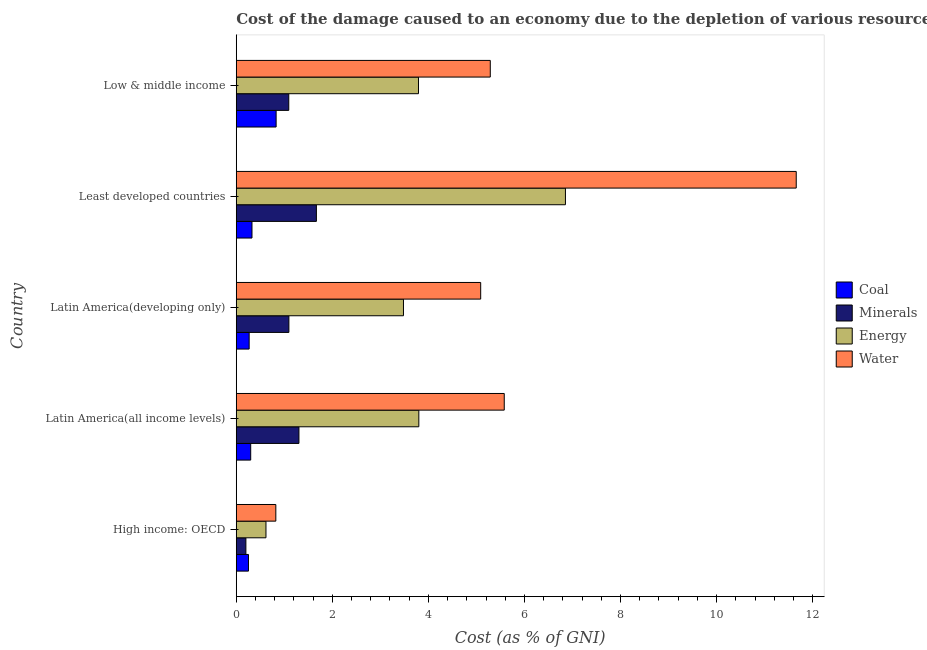How many groups of bars are there?
Keep it short and to the point. 5. Are the number of bars per tick equal to the number of legend labels?
Provide a succinct answer. Yes. How many bars are there on the 4th tick from the top?
Your answer should be compact. 4. What is the label of the 3rd group of bars from the top?
Provide a short and direct response. Latin America(developing only). In how many cases, is the number of bars for a given country not equal to the number of legend labels?
Offer a very short reply. 0. What is the cost of damage due to depletion of water in Latin America(all income levels)?
Give a very brief answer. 5.58. Across all countries, what is the maximum cost of damage due to depletion of coal?
Offer a very short reply. 0.83. Across all countries, what is the minimum cost of damage due to depletion of minerals?
Your answer should be compact. 0.2. In which country was the cost of damage due to depletion of energy maximum?
Keep it short and to the point. Least developed countries. In which country was the cost of damage due to depletion of coal minimum?
Your answer should be very brief. High income: OECD. What is the total cost of damage due to depletion of water in the graph?
Give a very brief answer. 28.44. What is the difference between the cost of damage due to depletion of coal in Latin America(developing only) and that in Low & middle income?
Your answer should be compact. -0.56. What is the difference between the cost of damage due to depletion of minerals in Low & middle income and the cost of damage due to depletion of energy in Latin America(developing only)?
Make the answer very short. -2.39. What is the average cost of damage due to depletion of energy per country?
Give a very brief answer. 3.71. What is the ratio of the cost of damage due to depletion of minerals in High income: OECD to that in Least developed countries?
Offer a terse response. 0.12. What is the difference between the highest and the second highest cost of damage due to depletion of water?
Make the answer very short. 6.08. What is the difference between the highest and the lowest cost of damage due to depletion of water?
Ensure brevity in your answer.  10.83. In how many countries, is the cost of damage due to depletion of minerals greater than the average cost of damage due to depletion of minerals taken over all countries?
Your answer should be compact. 4. Is the sum of the cost of damage due to depletion of minerals in High income: OECD and Latin America(all income levels) greater than the maximum cost of damage due to depletion of energy across all countries?
Offer a very short reply. No. Is it the case that in every country, the sum of the cost of damage due to depletion of water and cost of damage due to depletion of minerals is greater than the sum of cost of damage due to depletion of coal and cost of damage due to depletion of energy?
Offer a very short reply. No. What does the 2nd bar from the top in Least developed countries represents?
Provide a succinct answer. Energy. What does the 4th bar from the bottom in Least developed countries represents?
Make the answer very short. Water. Is it the case that in every country, the sum of the cost of damage due to depletion of coal and cost of damage due to depletion of minerals is greater than the cost of damage due to depletion of energy?
Ensure brevity in your answer.  No. How many bars are there?
Offer a very short reply. 20. What is the difference between two consecutive major ticks on the X-axis?
Make the answer very short. 2. Does the graph contain any zero values?
Keep it short and to the point. No. Where does the legend appear in the graph?
Make the answer very short. Center right. How many legend labels are there?
Keep it short and to the point. 4. How are the legend labels stacked?
Offer a very short reply. Vertical. What is the title of the graph?
Give a very brief answer. Cost of the damage caused to an economy due to the depletion of various resources in 2012 . What is the label or title of the X-axis?
Ensure brevity in your answer.  Cost (as % of GNI). What is the Cost (as % of GNI) in Coal in High income: OECD?
Give a very brief answer. 0.25. What is the Cost (as % of GNI) in Minerals in High income: OECD?
Make the answer very short. 0.2. What is the Cost (as % of GNI) of Energy in High income: OECD?
Your answer should be very brief. 0.62. What is the Cost (as % of GNI) in Water in High income: OECD?
Give a very brief answer. 0.82. What is the Cost (as % of GNI) in Coal in Latin America(all income levels)?
Ensure brevity in your answer.  0.3. What is the Cost (as % of GNI) in Minerals in Latin America(all income levels)?
Offer a terse response. 1.3. What is the Cost (as % of GNI) of Energy in Latin America(all income levels)?
Your answer should be very brief. 3.8. What is the Cost (as % of GNI) in Water in Latin America(all income levels)?
Offer a terse response. 5.58. What is the Cost (as % of GNI) in Coal in Latin America(developing only)?
Your answer should be compact. 0.27. What is the Cost (as % of GNI) in Minerals in Latin America(developing only)?
Make the answer very short. 1.1. What is the Cost (as % of GNI) in Energy in Latin America(developing only)?
Your response must be concise. 3.48. What is the Cost (as % of GNI) of Water in Latin America(developing only)?
Make the answer very short. 5.09. What is the Cost (as % of GNI) of Coal in Least developed countries?
Provide a short and direct response. 0.33. What is the Cost (as % of GNI) of Minerals in Least developed countries?
Your answer should be very brief. 1.67. What is the Cost (as % of GNI) in Energy in Least developed countries?
Your answer should be compact. 6.85. What is the Cost (as % of GNI) of Water in Least developed countries?
Make the answer very short. 11.66. What is the Cost (as % of GNI) of Coal in Low & middle income?
Make the answer very short. 0.83. What is the Cost (as % of GNI) of Minerals in Low & middle income?
Offer a very short reply. 1.09. What is the Cost (as % of GNI) in Energy in Low & middle income?
Your answer should be compact. 3.79. What is the Cost (as % of GNI) in Water in Low & middle income?
Provide a short and direct response. 5.29. Across all countries, what is the maximum Cost (as % of GNI) in Coal?
Give a very brief answer. 0.83. Across all countries, what is the maximum Cost (as % of GNI) in Minerals?
Give a very brief answer. 1.67. Across all countries, what is the maximum Cost (as % of GNI) of Energy?
Provide a succinct answer. 6.85. Across all countries, what is the maximum Cost (as % of GNI) of Water?
Keep it short and to the point. 11.66. Across all countries, what is the minimum Cost (as % of GNI) in Coal?
Provide a short and direct response. 0.25. Across all countries, what is the minimum Cost (as % of GNI) of Minerals?
Your answer should be very brief. 0.2. Across all countries, what is the minimum Cost (as % of GNI) of Energy?
Offer a terse response. 0.62. Across all countries, what is the minimum Cost (as % of GNI) of Water?
Your response must be concise. 0.82. What is the total Cost (as % of GNI) of Coal in the graph?
Offer a terse response. 1.98. What is the total Cost (as % of GNI) of Minerals in the graph?
Your answer should be very brief. 5.36. What is the total Cost (as % of GNI) in Energy in the graph?
Provide a short and direct response. 18.55. What is the total Cost (as % of GNI) in Water in the graph?
Your answer should be compact. 28.44. What is the difference between the Cost (as % of GNI) in Coal in High income: OECD and that in Latin America(all income levels)?
Offer a terse response. -0.05. What is the difference between the Cost (as % of GNI) of Minerals in High income: OECD and that in Latin America(all income levels)?
Keep it short and to the point. -1.1. What is the difference between the Cost (as % of GNI) in Energy in High income: OECD and that in Latin America(all income levels)?
Your response must be concise. -3.18. What is the difference between the Cost (as % of GNI) in Water in High income: OECD and that in Latin America(all income levels)?
Your answer should be compact. -4.76. What is the difference between the Cost (as % of GNI) of Coal in High income: OECD and that in Latin America(developing only)?
Offer a very short reply. -0.01. What is the difference between the Cost (as % of GNI) of Minerals in High income: OECD and that in Latin America(developing only)?
Offer a very short reply. -0.9. What is the difference between the Cost (as % of GNI) in Energy in High income: OECD and that in Latin America(developing only)?
Offer a very short reply. -2.86. What is the difference between the Cost (as % of GNI) in Water in High income: OECD and that in Latin America(developing only)?
Your answer should be very brief. -4.26. What is the difference between the Cost (as % of GNI) of Coal in High income: OECD and that in Least developed countries?
Your answer should be very brief. -0.07. What is the difference between the Cost (as % of GNI) of Minerals in High income: OECD and that in Least developed countries?
Make the answer very short. -1.47. What is the difference between the Cost (as % of GNI) of Energy in High income: OECD and that in Least developed countries?
Make the answer very short. -6.23. What is the difference between the Cost (as % of GNI) in Water in High income: OECD and that in Least developed countries?
Provide a short and direct response. -10.83. What is the difference between the Cost (as % of GNI) in Coal in High income: OECD and that in Low & middle income?
Keep it short and to the point. -0.58. What is the difference between the Cost (as % of GNI) of Minerals in High income: OECD and that in Low & middle income?
Provide a succinct answer. -0.89. What is the difference between the Cost (as % of GNI) of Energy in High income: OECD and that in Low & middle income?
Offer a terse response. -3.17. What is the difference between the Cost (as % of GNI) of Water in High income: OECD and that in Low & middle income?
Ensure brevity in your answer.  -4.46. What is the difference between the Cost (as % of GNI) of Coal in Latin America(all income levels) and that in Latin America(developing only)?
Provide a short and direct response. 0.03. What is the difference between the Cost (as % of GNI) of Minerals in Latin America(all income levels) and that in Latin America(developing only)?
Offer a very short reply. 0.21. What is the difference between the Cost (as % of GNI) in Energy in Latin America(all income levels) and that in Latin America(developing only)?
Offer a terse response. 0.32. What is the difference between the Cost (as % of GNI) in Water in Latin America(all income levels) and that in Latin America(developing only)?
Offer a terse response. 0.49. What is the difference between the Cost (as % of GNI) in Coal in Latin America(all income levels) and that in Least developed countries?
Your answer should be very brief. -0.03. What is the difference between the Cost (as % of GNI) of Minerals in Latin America(all income levels) and that in Least developed countries?
Offer a very short reply. -0.36. What is the difference between the Cost (as % of GNI) in Energy in Latin America(all income levels) and that in Least developed countries?
Make the answer very short. -3.05. What is the difference between the Cost (as % of GNI) in Water in Latin America(all income levels) and that in Least developed countries?
Ensure brevity in your answer.  -6.08. What is the difference between the Cost (as % of GNI) of Coal in Latin America(all income levels) and that in Low & middle income?
Provide a short and direct response. -0.53. What is the difference between the Cost (as % of GNI) of Minerals in Latin America(all income levels) and that in Low & middle income?
Give a very brief answer. 0.21. What is the difference between the Cost (as % of GNI) in Energy in Latin America(all income levels) and that in Low & middle income?
Your answer should be compact. 0.01. What is the difference between the Cost (as % of GNI) in Water in Latin America(all income levels) and that in Low & middle income?
Make the answer very short. 0.29. What is the difference between the Cost (as % of GNI) of Coal in Latin America(developing only) and that in Least developed countries?
Provide a short and direct response. -0.06. What is the difference between the Cost (as % of GNI) of Minerals in Latin America(developing only) and that in Least developed countries?
Your answer should be very brief. -0.57. What is the difference between the Cost (as % of GNI) of Energy in Latin America(developing only) and that in Least developed countries?
Provide a succinct answer. -3.37. What is the difference between the Cost (as % of GNI) in Water in Latin America(developing only) and that in Least developed countries?
Offer a terse response. -6.57. What is the difference between the Cost (as % of GNI) in Coal in Latin America(developing only) and that in Low & middle income?
Make the answer very short. -0.56. What is the difference between the Cost (as % of GNI) in Minerals in Latin America(developing only) and that in Low & middle income?
Your answer should be compact. 0. What is the difference between the Cost (as % of GNI) in Energy in Latin America(developing only) and that in Low & middle income?
Ensure brevity in your answer.  -0.31. What is the difference between the Cost (as % of GNI) of Water in Latin America(developing only) and that in Low & middle income?
Provide a succinct answer. -0.2. What is the difference between the Cost (as % of GNI) in Coal in Least developed countries and that in Low & middle income?
Provide a succinct answer. -0.5. What is the difference between the Cost (as % of GNI) of Minerals in Least developed countries and that in Low & middle income?
Offer a very short reply. 0.58. What is the difference between the Cost (as % of GNI) in Energy in Least developed countries and that in Low & middle income?
Offer a very short reply. 3.06. What is the difference between the Cost (as % of GNI) in Water in Least developed countries and that in Low & middle income?
Give a very brief answer. 6.37. What is the difference between the Cost (as % of GNI) of Coal in High income: OECD and the Cost (as % of GNI) of Minerals in Latin America(all income levels)?
Make the answer very short. -1.05. What is the difference between the Cost (as % of GNI) of Coal in High income: OECD and the Cost (as % of GNI) of Energy in Latin America(all income levels)?
Your answer should be compact. -3.55. What is the difference between the Cost (as % of GNI) in Coal in High income: OECD and the Cost (as % of GNI) in Water in Latin America(all income levels)?
Give a very brief answer. -5.32. What is the difference between the Cost (as % of GNI) of Minerals in High income: OECD and the Cost (as % of GNI) of Energy in Latin America(all income levels)?
Provide a succinct answer. -3.6. What is the difference between the Cost (as % of GNI) of Minerals in High income: OECD and the Cost (as % of GNI) of Water in Latin America(all income levels)?
Ensure brevity in your answer.  -5.38. What is the difference between the Cost (as % of GNI) of Energy in High income: OECD and the Cost (as % of GNI) of Water in Latin America(all income levels)?
Provide a short and direct response. -4.96. What is the difference between the Cost (as % of GNI) in Coal in High income: OECD and the Cost (as % of GNI) in Minerals in Latin America(developing only)?
Keep it short and to the point. -0.84. What is the difference between the Cost (as % of GNI) of Coal in High income: OECD and the Cost (as % of GNI) of Energy in Latin America(developing only)?
Your answer should be compact. -3.23. What is the difference between the Cost (as % of GNI) in Coal in High income: OECD and the Cost (as % of GNI) in Water in Latin America(developing only)?
Offer a very short reply. -4.83. What is the difference between the Cost (as % of GNI) of Minerals in High income: OECD and the Cost (as % of GNI) of Energy in Latin America(developing only)?
Your response must be concise. -3.28. What is the difference between the Cost (as % of GNI) of Minerals in High income: OECD and the Cost (as % of GNI) of Water in Latin America(developing only)?
Ensure brevity in your answer.  -4.89. What is the difference between the Cost (as % of GNI) of Energy in High income: OECD and the Cost (as % of GNI) of Water in Latin America(developing only)?
Keep it short and to the point. -4.47. What is the difference between the Cost (as % of GNI) of Coal in High income: OECD and the Cost (as % of GNI) of Minerals in Least developed countries?
Offer a very short reply. -1.41. What is the difference between the Cost (as % of GNI) of Coal in High income: OECD and the Cost (as % of GNI) of Energy in Least developed countries?
Provide a short and direct response. -6.6. What is the difference between the Cost (as % of GNI) in Coal in High income: OECD and the Cost (as % of GNI) in Water in Least developed countries?
Your response must be concise. -11.4. What is the difference between the Cost (as % of GNI) in Minerals in High income: OECD and the Cost (as % of GNI) in Energy in Least developed countries?
Provide a succinct answer. -6.65. What is the difference between the Cost (as % of GNI) in Minerals in High income: OECD and the Cost (as % of GNI) in Water in Least developed countries?
Provide a succinct answer. -11.46. What is the difference between the Cost (as % of GNI) of Energy in High income: OECD and the Cost (as % of GNI) of Water in Least developed countries?
Provide a short and direct response. -11.04. What is the difference between the Cost (as % of GNI) of Coal in High income: OECD and the Cost (as % of GNI) of Minerals in Low & middle income?
Your answer should be very brief. -0.84. What is the difference between the Cost (as % of GNI) of Coal in High income: OECD and the Cost (as % of GNI) of Energy in Low & middle income?
Your answer should be very brief. -3.54. What is the difference between the Cost (as % of GNI) in Coal in High income: OECD and the Cost (as % of GNI) in Water in Low & middle income?
Offer a very short reply. -5.03. What is the difference between the Cost (as % of GNI) of Minerals in High income: OECD and the Cost (as % of GNI) of Energy in Low & middle income?
Provide a short and direct response. -3.59. What is the difference between the Cost (as % of GNI) in Minerals in High income: OECD and the Cost (as % of GNI) in Water in Low & middle income?
Provide a succinct answer. -5.09. What is the difference between the Cost (as % of GNI) in Energy in High income: OECD and the Cost (as % of GNI) in Water in Low & middle income?
Ensure brevity in your answer.  -4.67. What is the difference between the Cost (as % of GNI) in Coal in Latin America(all income levels) and the Cost (as % of GNI) in Minerals in Latin America(developing only)?
Ensure brevity in your answer.  -0.8. What is the difference between the Cost (as % of GNI) in Coal in Latin America(all income levels) and the Cost (as % of GNI) in Energy in Latin America(developing only)?
Your answer should be very brief. -3.18. What is the difference between the Cost (as % of GNI) of Coal in Latin America(all income levels) and the Cost (as % of GNI) of Water in Latin America(developing only)?
Keep it short and to the point. -4.79. What is the difference between the Cost (as % of GNI) in Minerals in Latin America(all income levels) and the Cost (as % of GNI) in Energy in Latin America(developing only)?
Make the answer very short. -2.18. What is the difference between the Cost (as % of GNI) in Minerals in Latin America(all income levels) and the Cost (as % of GNI) in Water in Latin America(developing only)?
Ensure brevity in your answer.  -3.78. What is the difference between the Cost (as % of GNI) in Energy in Latin America(all income levels) and the Cost (as % of GNI) in Water in Latin America(developing only)?
Provide a succinct answer. -1.29. What is the difference between the Cost (as % of GNI) in Coal in Latin America(all income levels) and the Cost (as % of GNI) in Minerals in Least developed countries?
Provide a short and direct response. -1.37. What is the difference between the Cost (as % of GNI) in Coal in Latin America(all income levels) and the Cost (as % of GNI) in Energy in Least developed countries?
Offer a terse response. -6.55. What is the difference between the Cost (as % of GNI) of Coal in Latin America(all income levels) and the Cost (as % of GNI) of Water in Least developed countries?
Keep it short and to the point. -11.36. What is the difference between the Cost (as % of GNI) in Minerals in Latin America(all income levels) and the Cost (as % of GNI) in Energy in Least developed countries?
Provide a succinct answer. -5.55. What is the difference between the Cost (as % of GNI) of Minerals in Latin America(all income levels) and the Cost (as % of GNI) of Water in Least developed countries?
Offer a terse response. -10.35. What is the difference between the Cost (as % of GNI) in Energy in Latin America(all income levels) and the Cost (as % of GNI) in Water in Least developed countries?
Provide a succinct answer. -7.86. What is the difference between the Cost (as % of GNI) of Coal in Latin America(all income levels) and the Cost (as % of GNI) of Minerals in Low & middle income?
Offer a terse response. -0.79. What is the difference between the Cost (as % of GNI) of Coal in Latin America(all income levels) and the Cost (as % of GNI) of Energy in Low & middle income?
Provide a short and direct response. -3.49. What is the difference between the Cost (as % of GNI) in Coal in Latin America(all income levels) and the Cost (as % of GNI) in Water in Low & middle income?
Ensure brevity in your answer.  -4.99. What is the difference between the Cost (as % of GNI) in Minerals in Latin America(all income levels) and the Cost (as % of GNI) in Energy in Low & middle income?
Your answer should be compact. -2.49. What is the difference between the Cost (as % of GNI) in Minerals in Latin America(all income levels) and the Cost (as % of GNI) in Water in Low & middle income?
Offer a very short reply. -3.98. What is the difference between the Cost (as % of GNI) of Energy in Latin America(all income levels) and the Cost (as % of GNI) of Water in Low & middle income?
Make the answer very short. -1.49. What is the difference between the Cost (as % of GNI) in Coal in Latin America(developing only) and the Cost (as % of GNI) in Minerals in Least developed countries?
Provide a short and direct response. -1.4. What is the difference between the Cost (as % of GNI) of Coal in Latin America(developing only) and the Cost (as % of GNI) of Energy in Least developed countries?
Provide a short and direct response. -6.58. What is the difference between the Cost (as % of GNI) in Coal in Latin America(developing only) and the Cost (as % of GNI) in Water in Least developed countries?
Give a very brief answer. -11.39. What is the difference between the Cost (as % of GNI) in Minerals in Latin America(developing only) and the Cost (as % of GNI) in Energy in Least developed countries?
Make the answer very short. -5.76. What is the difference between the Cost (as % of GNI) of Minerals in Latin America(developing only) and the Cost (as % of GNI) of Water in Least developed countries?
Provide a succinct answer. -10.56. What is the difference between the Cost (as % of GNI) in Energy in Latin America(developing only) and the Cost (as % of GNI) in Water in Least developed countries?
Provide a short and direct response. -8.18. What is the difference between the Cost (as % of GNI) of Coal in Latin America(developing only) and the Cost (as % of GNI) of Minerals in Low & middle income?
Offer a terse response. -0.82. What is the difference between the Cost (as % of GNI) of Coal in Latin America(developing only) and the Cost (as % of GNI) of Energy in Low & middle income?
Provide a succinct answer. -3.52. What is the difference between the Cost (as % of GNI) of Coal in Latin America(developing only) and the Cost (as % of GNI) of Water in Low & middle income?
Ensure brevity in your answer.  -5.02. What is the difference between the Cost (as % of GNI) in Minerals in Latin America(developing only) and the Cost (as % of GNI) in Energy in Low & middle income?
Your response must be concise. -2.7. What is the difference between the Cost (as % of GNI) of Minerals in Latin America(developing only) and the Cost (as % of GNI) of Water in Low & middle income?
Your response must be concise. -4.19. What is the difference between the Cost (as % of GNI) in Energy in Latin America(developing only) and the Cost (as % of GNI) in Water in Low & middle income?
Your response must be concise. -1.81. What is the difference between the Cost (as % of GNI) in Coal in Least developed countries and the Cost (as % of GNI) in Minerals in Low & middle income?
Your answer should be very brief. -0.77. What is the difference between the Cost (as % of GNI) of Coal in Least developed countries and the Cost (as % of GNI) of Energy in Low & middle income?
Offer a terse response. -3.47. What is the difference between the Cost (as % of GNI) of Coal in Least developed countries and the Cost (as % of GNI) of Water in Low & middle income?
Give a very brief answer. -4.96. What is the difference between the Cost (as % of GNI) of Minerals in Least developed countries and the Cost (as % of GNI) of Energy in Low & middle income?
Make the answer very short. -2.13. What is the difference between the Cost (as % of GNI) of Minerals in Least developed countries and the Cost (as % of GNI) of Water in Low & middle income?
Your response must be concise. -3.62. What is the difference between the Cost (as % of GNI) of Energy in Least developed countries and the Cost (as % of GNI) of Water in Low & middle income?
Make the answer very short. 1.56. What is the average Cost (as % of GNI) of Coal per country?
Provide a short and direct response. 0.4. What is the average Cost (as % of GNI) of Minerals per country?
Offer a very short reply. 1.07. What is the average Cost (as % of GNI) of Energy per country?
Provide a short and direct response. 3.71. What is the average Cost (as % of GNI) in Water per country?
Give a very brief answer. 5.69. What is the difference between the Cost (as % of GNI) in Coal and Cost (as % of GNI) in Minerals in High income: OECD?
Offer a very short reply. 0.05. What is the difference between the Cost (as % of GNI) of Coal and Cost (as % of GNI) of Energy in High income: OECD?
Your response must be concise. -0.36. What is the difference between the Cost (as % of GNI) in Coal and Cost (as % of GNI) in Water in High income: OECD?
Provide a succinct answer. -0.57. What is the difference between the Cost (as % of GNI) in Minerals and Cost (as % of GNI) in Energy in High income: OECD?
Keep it short and to the point. -0.42. What is the difference between the Cost (as % of GNI) in Minerals and Cost (as % of GNI) in Water in High income: OECD?
Ensure brevity in your answer.  -0.62. What is the difference between the Cost (as % of GNI) in Energy and Cost (as % of GNI) in Water in High income: OECD?
Offer a very short reply. -0.2. What is the difference between the Cost (as % of GNI) in Coal and Cost (as % of GNI) in Minerals in Latin America(all income levels)?
Ensure brevity in your answer.  -1. What is the difference between the Cost (as % of GNI) in Coal and Cost (as % of GNI) in Energy in Latin America(all income levels)?
Offer a very short reply. -3.5. What is the difference between the Cost (as % of GNI) of Coal and Cost (as % of GNI) of Water in Latin America(all income levels)?
Give a very brief answer. -5.28. What is the difference between the Cost (as % of GNI) of Minerals and Cost (as % of GNI) of Energy in Latin America(all income levels)?
Your answer should be compact. -2.5. What is the difference between the Cost (as % of GNI) of Minerals and Cost (as % of GNI) of Water in Latin America(all income levels)?
Provide a succinct answer. -4.27. What is the difference between the Cost (as % of GNI) of Energy and Cost (as % of GNI) of Water in Latin America(all income levels)?
Offer a terse response. -1.78. What is the difference between the Cost (as % of GNI) of Coal and Cost (as % of GNI) of Minerals in Latin America(developing only)?
Offer a very short reply. -0.83. What is the difference between the Cost (as % of GNI) of Coal and Cost (as % of GNI) of Energy in Latin America(developing only)?
Your answer should be compact. -3.21. What is the difference between the Cost (as % of GNI) of Coal and Cost (as % of GNI) of Water in Latin America(developing only)?
Ensure brevity in your answer.  -4.82. What is the difference between the Cost (as % of GNI) of Minerals and Cost (as % of GNI) of Energy in Latin America(developing only)?
Offer a very short reply. -2.38. What is the difference between the Cost (as % of GNI) of Minerals and Cost (as % of GNI) of Water in Latin America(developing only)?
Offer a terse response. -3.99. What is the difference between the Cost (as % of GNI) in Energy and Cost (as % of GNI) in Water in Latin America(developing only)?
Give a very brief answer. -1.61. What is the difference between the Cost (as % of GNI) of Coal and Cost (as % of GNI) of Minerals in Least developed countries?
Give a very brief answer. -1.34. What is the difference between the Cost (as % of GNI) of Coal and Cost (as % of GNI) of Energy in Least developed countries?
Offer a very short reply. -6.53. What is the difference between the Cost (as % of GNI) of Coal and Cost (as % of GNI) of Water in Least developed countries?
Provide a succinct answer. -11.33. What is the difference between the Cost (as % of GNI) in Minerals and Cost (as % of GNI) in Energy in Least developed countries?
Give a very brief answer. -5.18. What is the difference between the Cost (as % of GNI) in Minerals and Cost (as % of GNI) in Water in Least developed countries?
Ensure brevity in your answer.  -9.99. What is the difference between the Cost (as % of GNI) in Energy and Cost (as % of GNI) in Water in Least developed countries?
Make the answer very short. -4.8. What is the difference between the Cost (as % of GNI) in Coal and Cost (as % of GNI) in Minerals in Low & middle income?
Keep it short and to the point. -0.26. What is the difference between the Cost (as % of GNI) of Coal and Cost (as % of GNI) of Energy in Low & middle income?
Give a very brief answer. -2.96. What is the difference between the Cost (as % of GNI) in Coal and Cost (as % of GNI) in Water in Low & middle income?
Keep it short and to the point. -4.46. What is the difference between the Cost (as % of GNI) in Minerals and Cost (as % of GNI) in Energy in Low & middle income?
Offer a very short reply. -2.7. What is the difference between the Cost (as % of GNI) in Minerals and Cost (as % of GNI) in Water in Low & middle income?
Ensure brevity in your answer.  -4.2. What is the difference between the Cost (as % of GNI) in Energy and Cost (as % of GNI) in Water in Low & middle income?
Ensure brevity in your answer.  -1.49. What is the ratio of the Cost (as % of GNI) of Coal in High income: OECD to that in Latin America(all income levels)?
Make the answer very short. 0.85. What is the ratio of the Cost (as % of GNI) of Minerals in High income: OECD to that in Latin America(all income levels)?
Offer a very short reply. 0.15. What is the ratio of the Cost (as % of GNI) in Energy in High income: OECD to that in Latin America(all income levels)?
Your response must be concise. 0.16. What is the ratio of the Cost (as % of GNI) in Water in High income: OECD to that in Latin America(all income levels)?
Provide a short and direct response. 0.15. What is the ratio of the Cost (as % of GNI) in Coal in High income: OECD to that in Latin America(developing only)?
Offer a very short reply. 0.95. What is the ratio of the Cost (as % of GNI) of Minerals in High income: OECD to that in Latin America(developing only)?
Keep it short and to the point. 0.18. What is the ratio of the Cost (as % of GNI) of Energy in High income: OECD to that in Latin America(developing only)?
Make the answer very short. 0.18. What is the ratio of the Cost (as % of GNI) of Water in High income: OECD to that in Latin America(developing only)?
Offer a very short reply. 0.16. What is the ratio of the Cost (as % of GNI) in Coal in High income: OECD to that in Least developed countries?
Make the answer very short. 0.78. What is the ratio of the Cost (as % of GNI) of Minerals in High income: OECD to that in Least developed countries?
Offer a very short reply. 0.12. What is the ratio of the Cost (as % of GNI) in Energy in High income: OECD to that in Least developed countries?
Provide a short and direct response. 0.09. What is the ratio of the Cost (as % of GNI) in Water in High income: OECD to that in Least developed countries?
Ensure brevity in your answer.  0.07. What is the ratio of the Cost (as % of GNI) of Coal in High income: OECD to that in Low & middle income?
Provide a short and direct response. 0.31. What is the ratio of the Cost (as % of GNI) in Minerals in High income: OECD to that in Low & middle income?
Provide a short and direct response. 0.18. What is the ratio of the Cost (as % of GNI) of Energy in High income: OECD to that in Low & middle income?
Your response must be concise. 0.16. What is the ratio of the Cost (as % of GNI) of Water in High income: OECD to that in Low & middle income?
Give a very brief answer. 0.16. What is the ratio of the Cost (as % of GNI) in Coal in Latin America(all income levels) to that in Latin America(developing only)?
Your answer should be compact. 1.12. What is the ratio of the Cost (as % of GNI) of Minerals in Latin America(all income levels) to that in Latin America(developing only)?
Your response must be concise. 1.19. What is the ratio of the Cost (as % of GNI) in Energy in Latin America(all income levels) to that in Latin America(developing only)?
Give a very brief answer. 1.09. What is the ratio of the Cost (as % of GNI) of Water in Latin America(all income levels) to that in Latin America(developing only)?
Offer a very short reply. 1.1. What is the ratio of the Cost (as % of GNI) in Coal in Latin America(all income levels) to that in Least developed countries?
Offer a very short reply. 0.92. What is the ratio of the Cost (as % of GNI) in Minerals in Latin America(all income levels) to that in Least developed countries?
Provide a short and direct response. 0.78. What is the ratio of the Cost (as % of GNI) in Energy in Latin America(all income levels) to that in Least developed countries?
Ensure brevity in your answer.  0.55. What is the ratio of the Cost (as % of GNI) of Water in Latin America(all income levels) to that in Least developed countries?
Your answer should be compact. 0.48. What is the ratio of the Cost (as % of GNI) of Coal in Latin America(all income levels) to that in Low & middle income?
Ensure brevity in your answer.  0.36. What is the ratio of the Cost (as % of GNI) in Minerals in Latin America(all income levels) to that in Low & middle income?
Ensure brevity in your answer.  1.19. What is the ratio of the Cost (as % of GNI) of Energy in Latin America(all income levels) to that in Low & middle income?
Your answer should be compact. 1. What is the ratio of the Cost (as % of GNI) in Water in Latin America(all income levels) to that in Low & middle income?
Your response must be concise. 1.05. What is the ratio of the Cost (as % of GNI) in Coal in Latin America(developing only) to that in Least developed countries?
Your answer should be very brief. 0.82. What is the ratio of the Cost (as % of GNI) in Minerals in Latin America(developing only) to that in Least developed countries?
Offer a terse response. 0.66. What is the ratio of the Cost (as % of GNI) in Energy in Latin America(developing only) to that in Least developed countries?
Give a very brief answer. 0.51. What is the ratio of the Cost (as % of GNI) of Water in Latin America(developing only) to that in Least developed countries?
Your answer should be compact. 0.44. What is the ratio of the Cost (as % of GNI) of Coal in Latin America(developing only) to that in Low & middle income?
Keep it short and to the point. 0.32. What is the ratio of the Cost (as % of GNI) in Energy in Latin America(developing only) to that in Low & middle income?
Ensure brevity in your answer.  0.92. What is the ratio of the Cost (as % of GNI) in Water in Latin America(developing only) to that in Low & middle income?
Your response must be concise. 0.96. What is the ratio of the Cost (as % of GNI) of Coal in Least developed countries to that in Low & middle income?
Ensure brevity in your answer.  0.39. What is the ratio of the Cost (as % of GNI) of Minerals in Least developed countries to that in Low & middle income?
Ensure brevity in your answer.  1.53. What is the ratio of the Cost (as % of GNI) of Energy in Least developed countries to that in Low & middle income?
Offer a terse response. 1.81. What is the ratio of the Cost (as % of GNI) in Water in Least developed countries to that in Low & middle income?
Offer a very short reply. 2.2. What is the difference between the highest and the second highest Cost (as % of GNI) in Coal?
Keep it short and to the point. 0.5. What is the difference between the highest and the second highest Cost (as % of GNI) in Minerals?
Your answer should be very brief. 0.36. What is the difference between the highest and the second highest Cost (as % of GNI) of Energy?
Your answer should be compact. 3.05. What is the difference between the highest and the second highest Cost (as % of GNI) of Water?
Offer a terse response. 6.08. What is the difference between the highest and the lowest Cost (as % of GNI) in Coal?
Your answer should be compact. 0.58. What is the difference between the highest and the lowest Cost (as % of GNI) of Minerals?
Your response must be concise. 1.47. What is the difference between the highest and the lowest Cost (as % of GNI) in Energy?
Offer a very short reply. 6.23. What is the difference between the highest and the lowest Cost (as % of GNI) of Water?
Your answer should be compact. 10.83. 